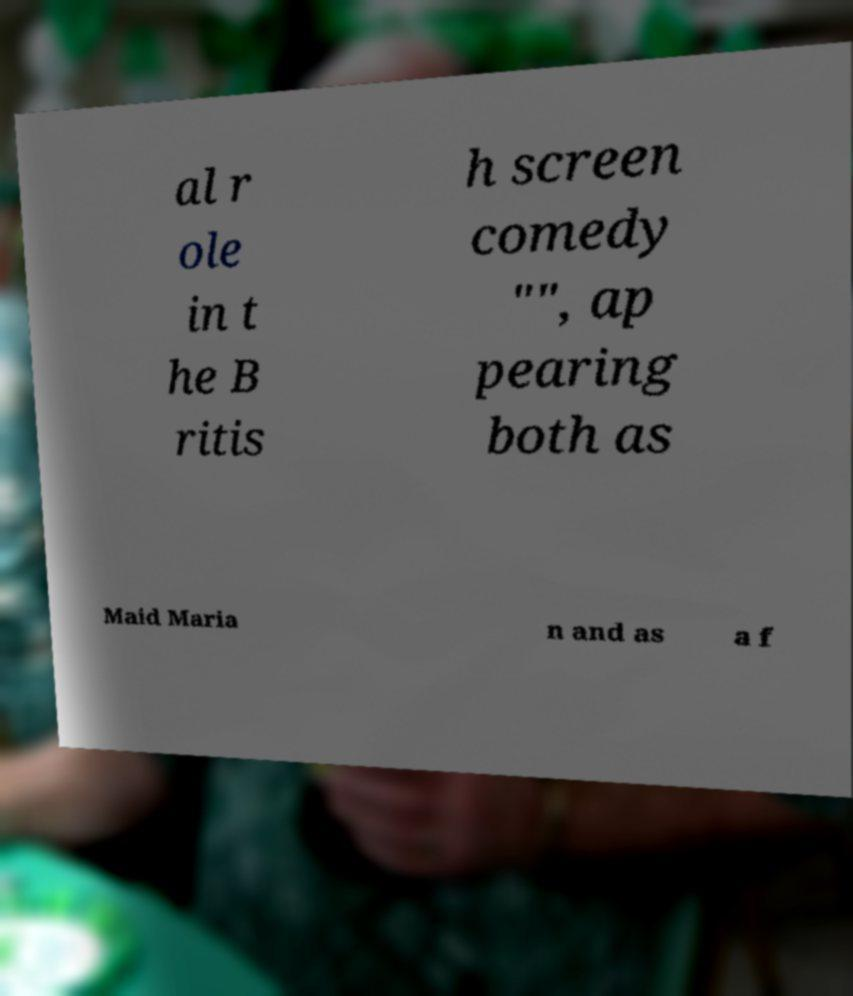Could you assist in decoding the text presented in this image and type it out clearly? al r ole in t he B ritis h screen comedy "", ap pearing both as Maid Maria n and as a f 